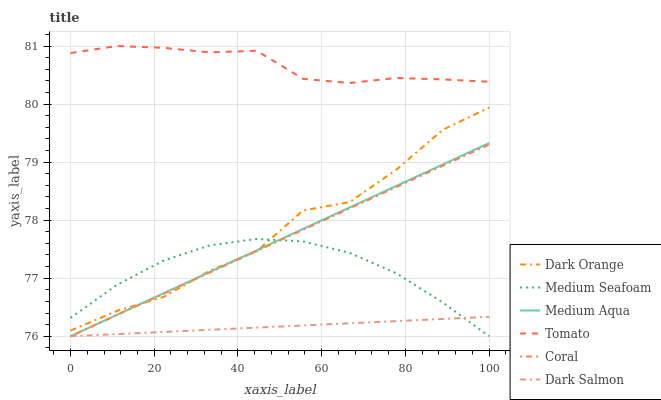Does Dark Salmon have the minimum area under the curve?
Answer yes or no. Yes. Does Tomato have the maximum area under the curve?
Answer yes or no. Yes. Does Dark Orange have the minimum area under the curve?
Answer yes or no. No. Does Dark Orange have the maximum area under the curve?
Answer yes or no. No. Is Coral the smoothest?
Answer yes or no. Yes. Is Dark Orange the roughest?
Answer yes or no. Yes. Is Dark Orange the smoothest?
Answer yes or no. No. Is Coral the roughest?
Answer yes or no. No. Does Coral have the lowest value?
Answer yes or no. Yes. Does Dark Orange have the lowest value?
Answer yes or no. No. Does Tomato have the highest value?
Answer yes or no. Yes. Does Dark Orange have the highest value?
Answer yes or no. No. Is Dark Orange less than Tomato?
Answer yes or no. Yes. Is Tomato greater than Medium Aqua?
Answer yes or no. Yes. Does Dark Orange intersect Medium Seafoam?
Answer yes or no. Yes. Is Dark Orange less than Medium Seafoam?
Answer yes or no. No. Is Dark Orange greater than Medium Seafoam?
Answer yes or no. No. Does Dark Orange intersect Tomato?
Answer yes or no. No. 